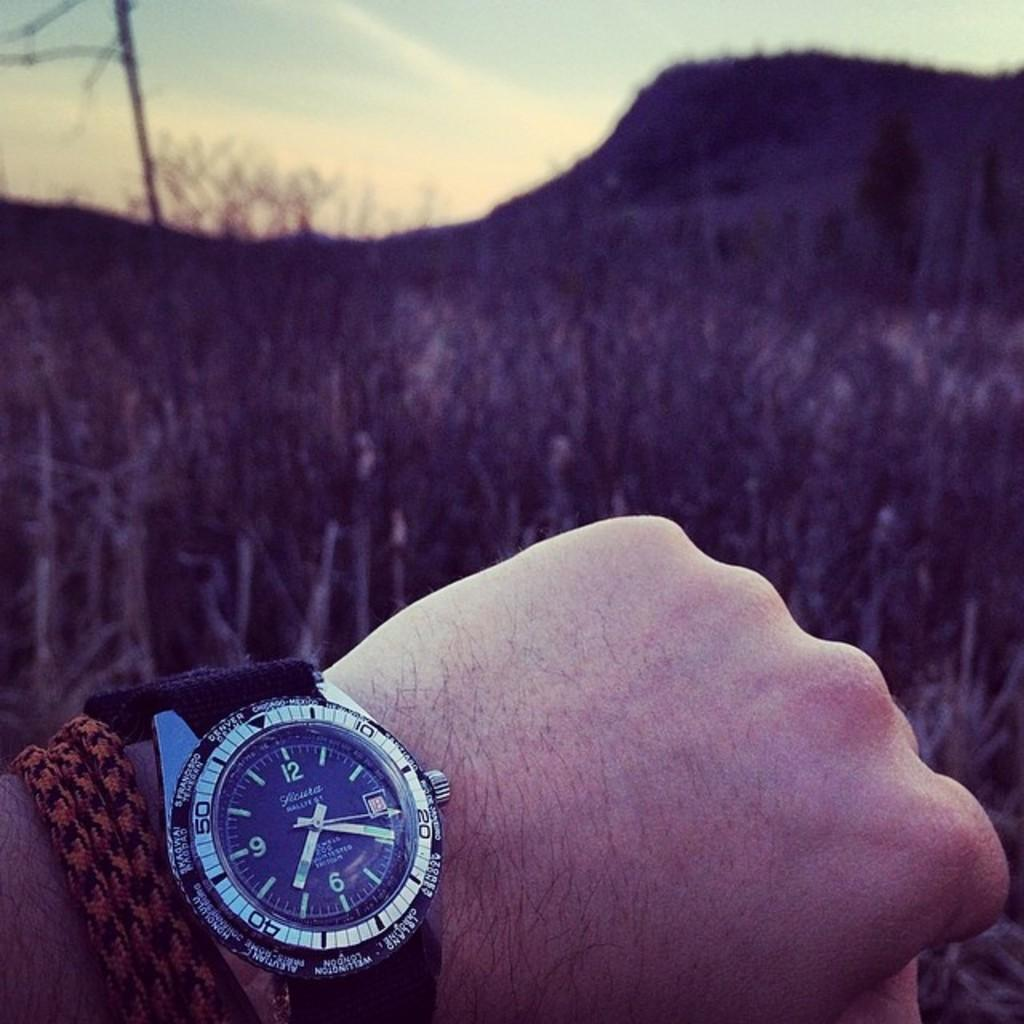Provide a one-sentence caption for the provided image. A hand with a watch can be seen in front of a field with the second arrow pointing to the number 20. 